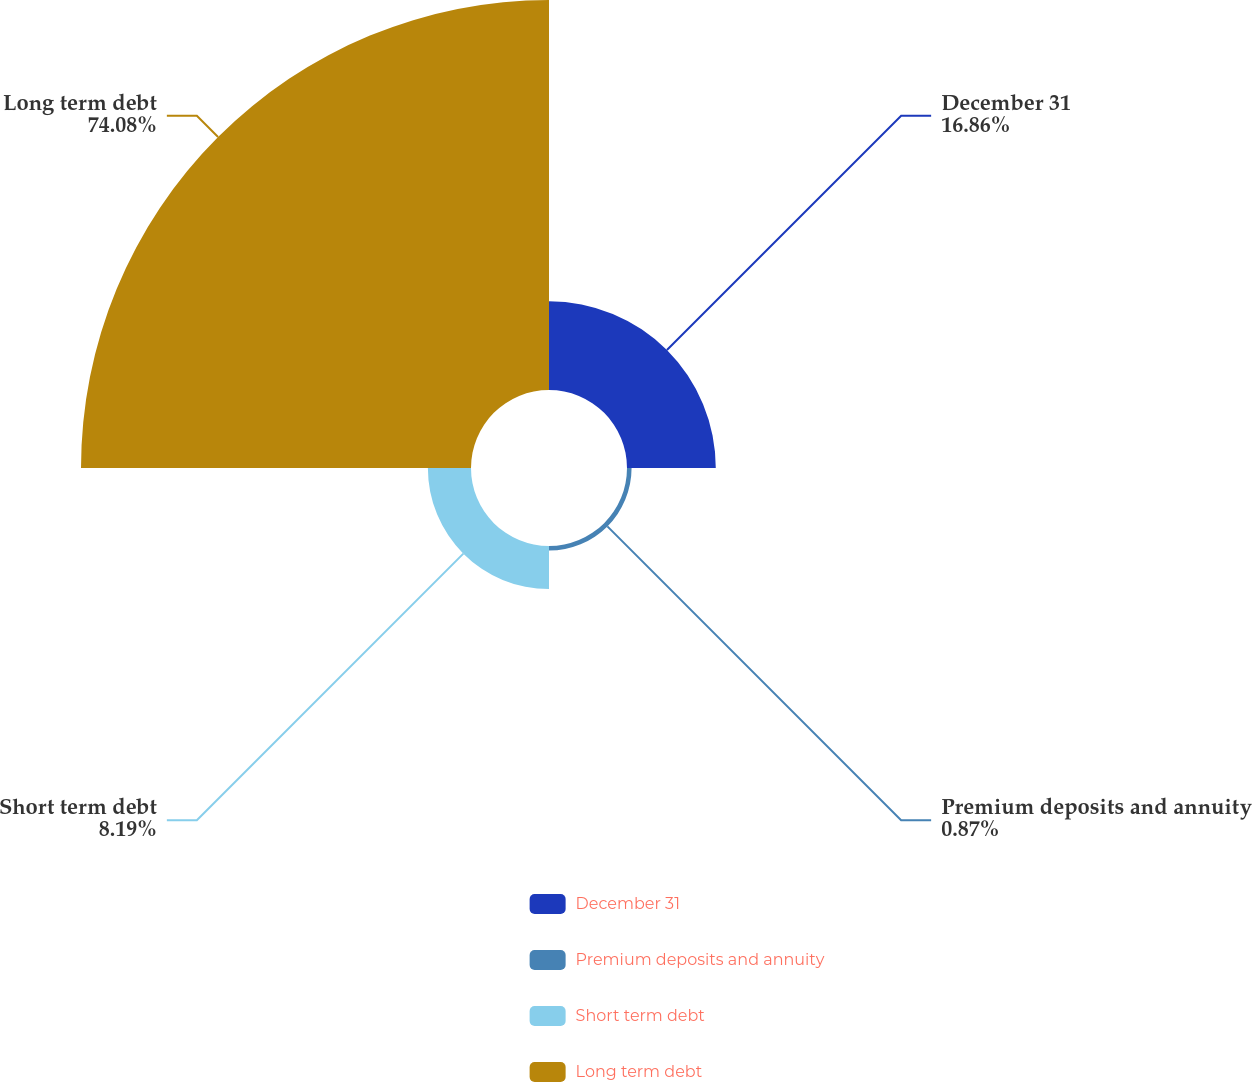Convert chart. <chart><loc_0><loc_0><loc_500><loc_500><pie_chart><fcel>December 31<fcel>Premium deposits and annuity<fcel>Short term debt<fcel>Long term debt<nl><fcel>16.86%<fcel>0.87%<fcel>8.19%<fcel>74.07%<nl></chart> 